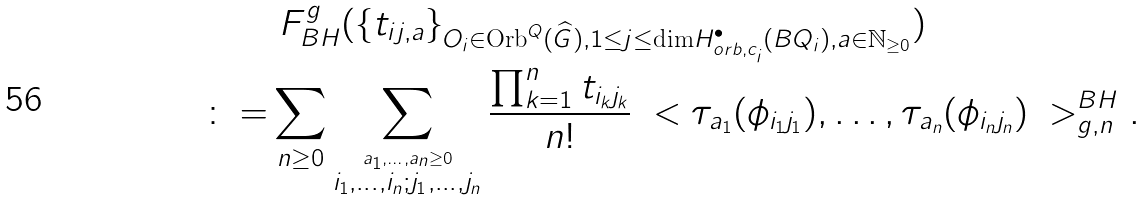Convert formula to latex. <formula><loc_0><loc_0><loc_500><loc_500>& \ F ^ { g } _ { B H } ( \{ t _ { i j , a } \} _ { O _ { i } \in \text {Orb} ^ { Q } ( \widehat { G } ) , 1 \leq j \leq \text {dim} H _ { o r b , c _ { i } } ^ { \bullet } ( B Q _ { i } ) , a \in \mathbb { N } _ { \geq 0 } } ) \\ \colon = & \sum _ { n \geq 0 } \sum _ { \overset { a _ { 1 } , \dots , a _ { n } \geq 0 } { i _ { 1 } , \dots , i _ { n } ; j _ { 1 } , \dots , j _ { n } } } \frac { \prod _ { k = 1 } ^ { n } t _ { i _ { k } j _ { k } } } { n ! } \ < \tau _ { a _ { 1 } } ( \phi _ { i _ { 1 } j _ { 1 } } ) , \dots , \tau _ { a _ { n } } ( \phi _ { i _ { n } j _ { n } } ) \ > _ { g , n } ^ { B H } .</formula> 